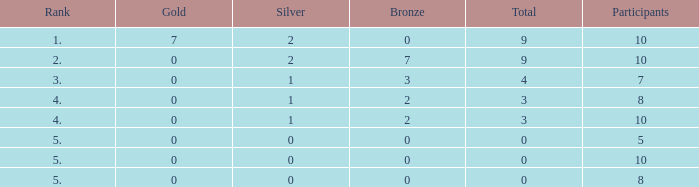What is the total rank for gold amounts smaller than 0? None. 